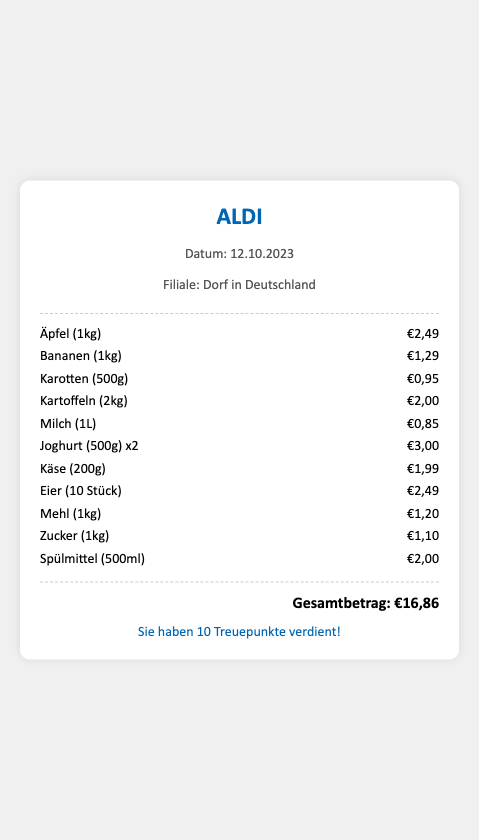What is the date of the transaction? The date of the transaction is specified in the document.
Answer: 12.10.2023 What is the total amount spent? The total amount spent is displayed in the document.
Answer: €16,86 How many loyalty points were earned? The number of loyalty points earned is mentioned at the bottom of the document.
Answer: 10 Treuepunkte What is the weight of the apples purchased? The weight of the apples is provided in the description of the item.
Answer: 1kg How many eggs are included in the purchase? The number of eggs is listed within the item description on the receipt.
Answer: 10 Stück What is the price of the bananas? The price for the bananas is clearly shown next to the item.
Answer: €1,29 Which household essential product was bought? There is a specific item categorized as a household essential in the list.
Answer: Spülmittel What is the total weight of the potatoes purchased? The total weight of the potatoes is indicated next to the item description.
Answer: 2kg How much did the yogurt cost in total? The cost of the yogurt is shown for the quantity purchased in the document.
Answer: €3,00 